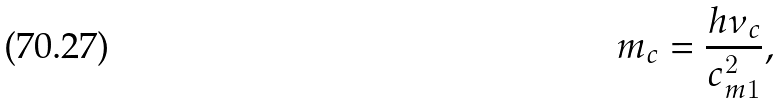Convert formula to latex. <formula><loc_0><loc_0><loc_500><loc_500>m _ { c } = \frac { h \nu _ { c } } { c _ { m 1 } ^ { 2 } } ,</formula> 